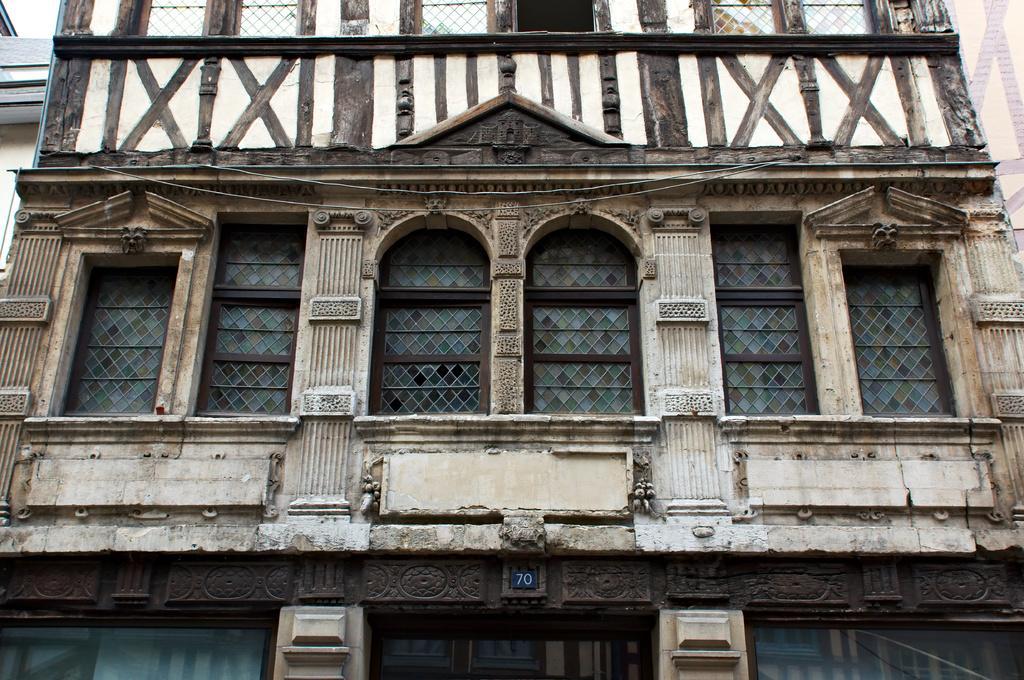Please provide a concise description of this image. In this image we can see building, windows, wallboard, door are present. 